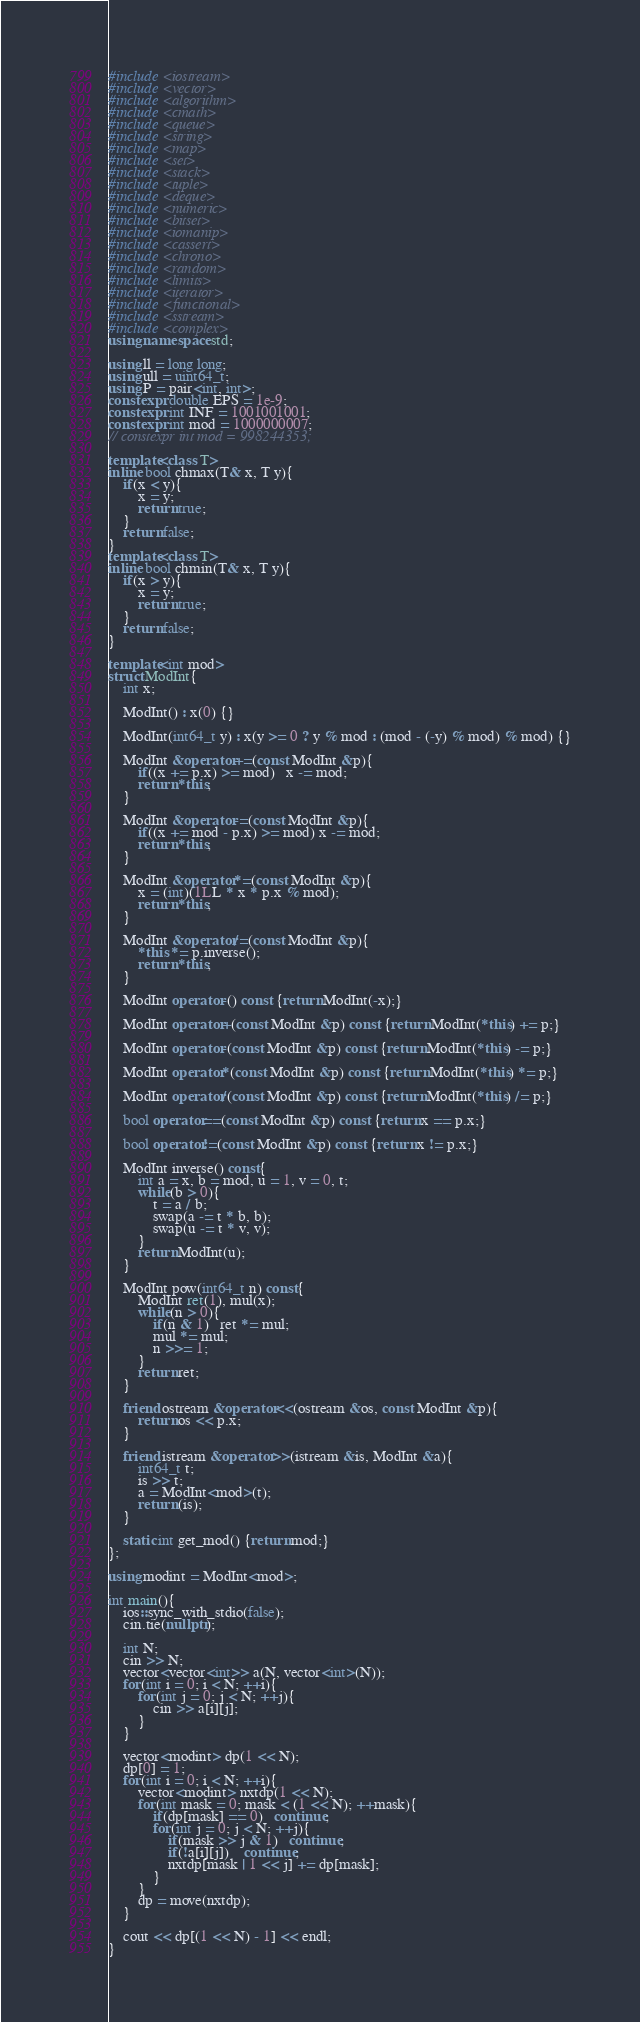<code> <loc_0><loc_0><loc_500><loc_500><_C++_>#include <iostream>
#include <vector>
#include <algorithm>
#include <cmath>
#include <queue>
#include <string>
#include <map>
#include <set>
#include <stack>
#include <tuple>
#include <deque>
#include <numeric>
#include <bitset>
#include <iomanip>
#include <cassert>
#include <chrono>
#include <random>
#include <limits>
#include <iterator>
#include <functional>
#include <sstream>
#include <complex>
using namespace std;

using ll = long long;
using ull = uint64_t;
using P = pair<int, int>;
constexpr double EPS = 1e-9;
constexpr int INF = 1001001001;
constexpr int mod = 1000000007;
// constexpr int mod = 998244353;

template<class T>
inline bool chmax(T& x, T y){
    if(x < y){
        x = y;
        return true;
    }
    return false;
}
template<class T>
inline bool chmin(T& x, T y){
    if(x > y){
        x = y;
        return true;
    }
    return false;
}

template<int mod>
struct ModInt{
    int x;

    ModInt() : x(0) {}
    
    ModInt(int64_t y) : x(y >= 0 ? y % mod : (mod - (-y) % mod) % mod) {}
    
    ModInt &operator+=(const ModInt &p){
        if((x += p.x) >= mod)   x -= mod;
        return *this;
    }
    
    ModInt &operator-=(const ModInt &p){
        if((x += mod - p.x) >= mod) x -= mod;
        return *this;
    }

    ModInt &operator*=(const ModInt &p){
        x = (int)(1LL * x * p.x % mod);
        return *this;
    }

    ModInt &operator/=(const ModInt &p){
        *this *= p.inverse();
        return *this;
    }
    
    ModInt operator-() const {return ModInt(-x);}

    ModInt operator+(const ModInt &p) const {return ModInt(*this) += p;}

    ModInt operator-(const ModInt &p) const {return ModInt(*this) -= p;}

    ModInt operator*(const ModInt &p) const {return ModInt(*this) *= p;}

    ModInt operator/(const ModInt &p) const {return ModInt(*this) /= p;}

    bool operator==(const ModInt &p) const {return x == p.x;}

    bool operator!=(const ModInt &p) const {return x != p.x;}

    ModInt inverse() const{
        int a = x, b = mod, u = 1, v = 0, t;
        while(b > 0){
            t = a / b;
            swap(a -= t * b, b);
            swap(u -= t * v, v);
        }
        return ModInt(u);
    }

    ModInt pow(int64_t n) const{
        ModInt ret(1), mul(x);
        while(n > 0){
            if(n & 1)   ret *= mul;
            mul *= mul;
            n >>= 1;
        }
        return ret;
    }

    friend ostream &operator<<(ostream &os, const ModInt &p){
        return os << p.x;
    }

    friend istream &operator>>(istream &is, ModInt &a){
        int64_t t;
        is >> t;
        a = ModInt<mod>(t);
        return (is);
    }

    static int get_mod() {return mod;}
};

using modint = ModInt<mod>;

int main(){
    ios::sync_with_stdio(false);
    cin.tie(nullptr);

    int N;
    cin >> N;
    vector<vector<int>> a(N, vector<int>(N));
    for(int i = 0; i < N; ++i){
        for(int j = 0; j < N; ++j){
            cin >> a[i][j];
        }
    }

    vector<modint> dp(1 << N);
    dp[0] = 1;
    for(int i = 0; i < N; ++i){
        vector<modint> nxtdp(1 << N);
        for(int mask = 0; mask < (1 << N); ++mask){
            if(dp[mask] == 0)   continue;
            for(int j = 0; j < N; ++j){
                if(mask >> j & 1)   continue;
                if(!a[i][j])    continue;
                nxtdp[mask | 1 << j] += dp[mask];
            }
        }
        dp = move(nxtdp);
    }

    cout << dp[(1 << N) - 1] << endl;
}</code> 